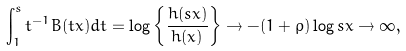Convert formula to latex. <formula><loc_0><loc_0><loc_500><loc_500>\int _ { 1 } ^ { s } t ^ { - 1 } B ( t x ) d t = \log \left \{ \frac { h ( s x ) } { h ( x ) } \right \} \rightarrow - ( 1 + \rho ) \log s x \rightarrow \infty ,</formula> 